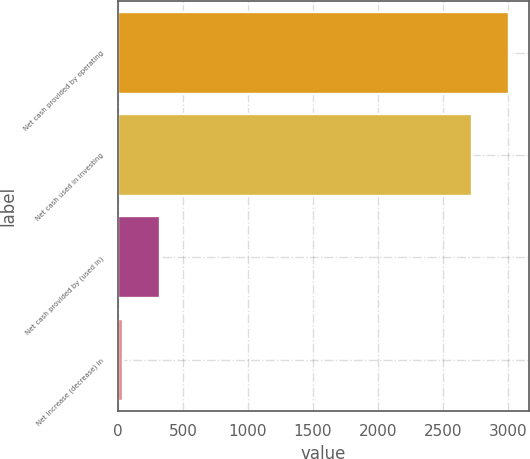Convert chart. <chart><loc_0><loc_0><loc_500><loc_500><bar_chart><fcel>Net cash provided by operating<fcel>Net cash used in investing<fcel>Net cash provided by (used in)<fcel>Net increase (decrease) in<nl><fcel>3009.4<fcel>2726<fcel>320.4<fcel>37<nl></chart> 